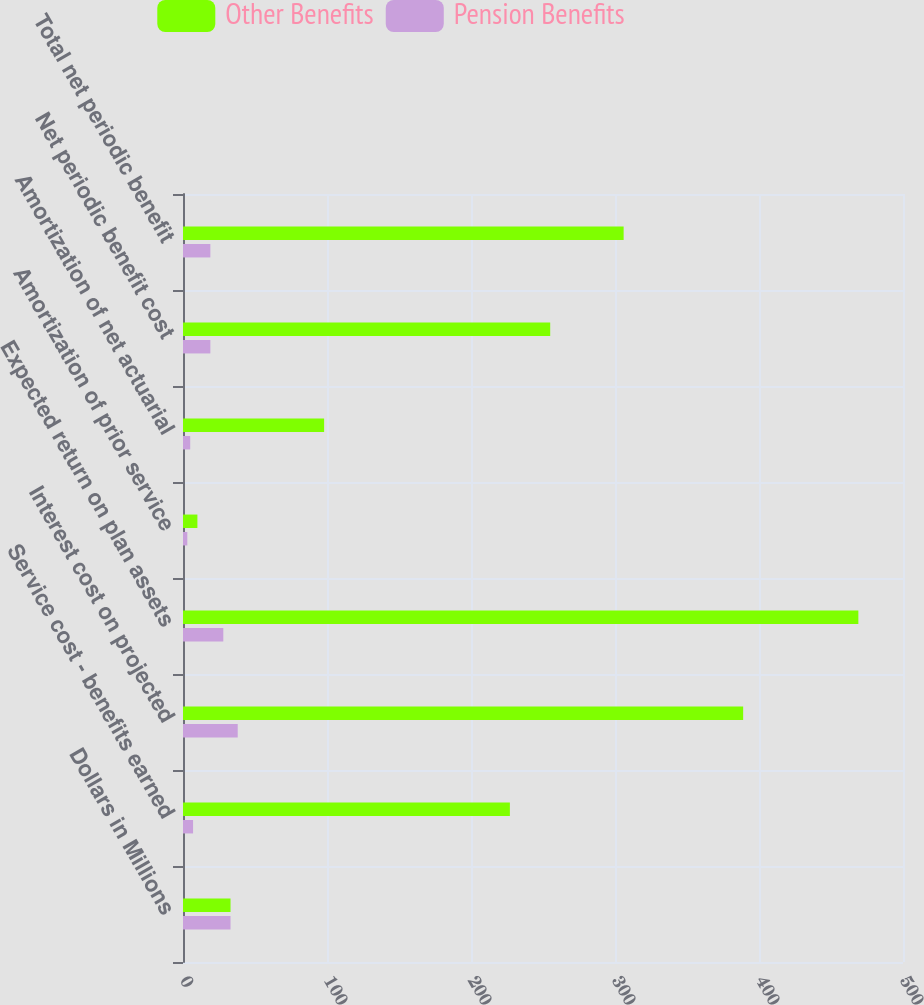<chart> <loc_0><loc_0><loc_500><loc_500><stacked_bar_chart><ecel><fcel>Dollars in Millions<fcel>Service cost - benefits earned<fcel>Interest cost on projected<fcel>Expected return on plan assets<fcel>Amortization of prior service<fcel>Amortization of net actuarial<fcel>Net periodic benefit cost<fcel>Total net periodic benefit<nl><fcel>Other Benefits<fcel>33<fcel>227<fcel>389<fcel>469<fcel>10<fcel>98<fcel>255<fcel>306<nl><fcel>Pension Benefits<fcel>33<fcel>7<fcel>38<fcel>28<fcel>3<fcel>5<fcel>19<fcel>19<nl></chart> 